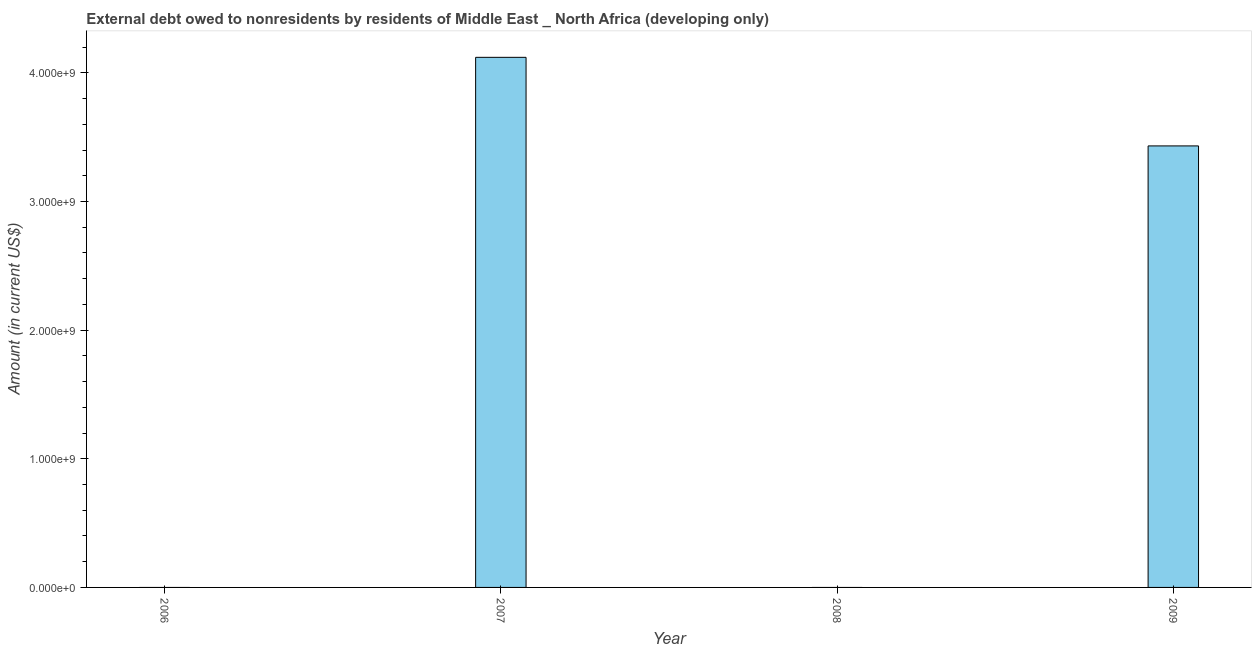Does the graph contain grids?
Make the answer very short. No. What is the title of the graph?
Provide a short and direct response. External debt owed to nonresidents by residents of Middle East _ North Africa (developing only). What is the label or title of the Y-axis?
Offer a terse response. Amount (in current US$). What is the debt in 2008?
Keep it short and to the point. 0. Across all years, what is the maximum debt?
Provide a short and direct response. 4.12e+09. Across all years, what is the minimum debt?
Ensure brevity in your answer.  0. In which year was the debt maximum?
Ensure brevity in your answer.  2007. What is the sum of the debt?
Provide a short and direct response. 7.55e+09. What is the difference between the debt in 2007 and 2009?
Provide a short and direct response. 6.89e+08. What is the average debt per year?
Provide a short and direct response. 1.89e+09. What is the median debt?
Your answer should be compact. 1.72e+09. In how many years, is the debt greater than 1800000000 US$?
Offer a terse response. 2. What is the difference between the highest and the lowest debt?
Your answer should be compact. 4.12e+09. In how many years, is the debt greater than the average debt taken over all years?
Provide a short and direct response. 2. Are all the bars in the graph horizontal?
Offer a very short reply. No. What is the difference between two consecutive major ticks on the Y-axis?
Your response must be concise. 1.00e+09. Are the values on the major ticks of Y-axis written in scientific E-notation?
Your response must be concise. Yes. What is the Amount (in current US$) in 2007?
Give a very brief answer. 4.12e+09. What is the Amount (in current US$) of 2009?
Ensure brevity in your answer.  3.43e+09. What is the difference between the Amount (in current US$) in 2007 and 2009?
Your response must be concise. 6.89e+08. What is the ratio of the Amount (in current US$) in 2007 to that in 2009?
Provide a succinct answer. 1.2. 